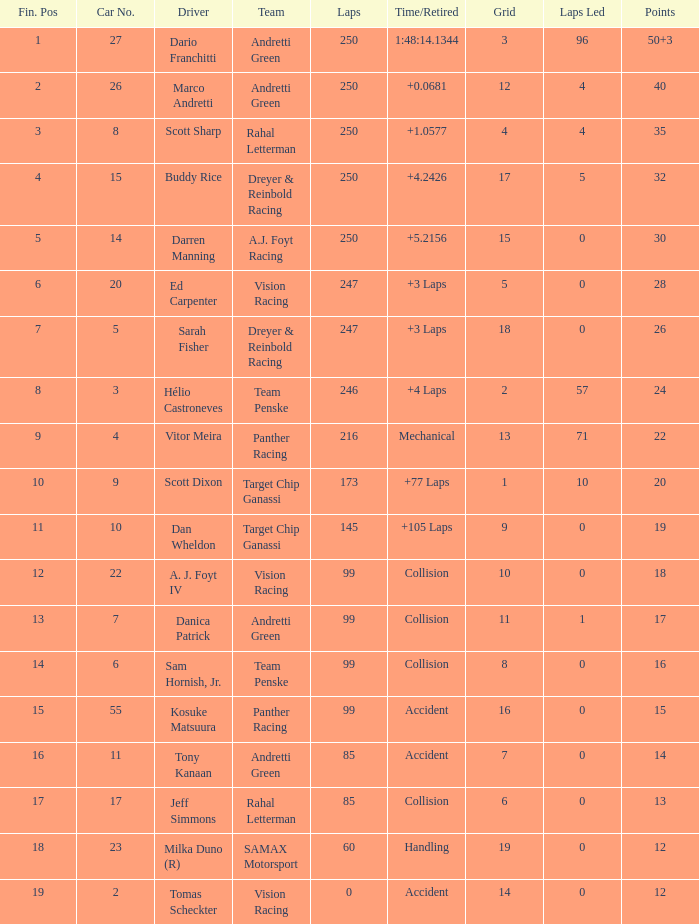What is the driver's grid position who secured 14 points? 7.0. 